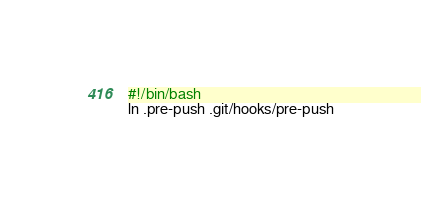Convert code to text. <code><loc_0><loc_0><loc_500><loc_500><_Bash_>#!/bin/bash
ln .pre-push .git/hooks/pre-push
</code> 